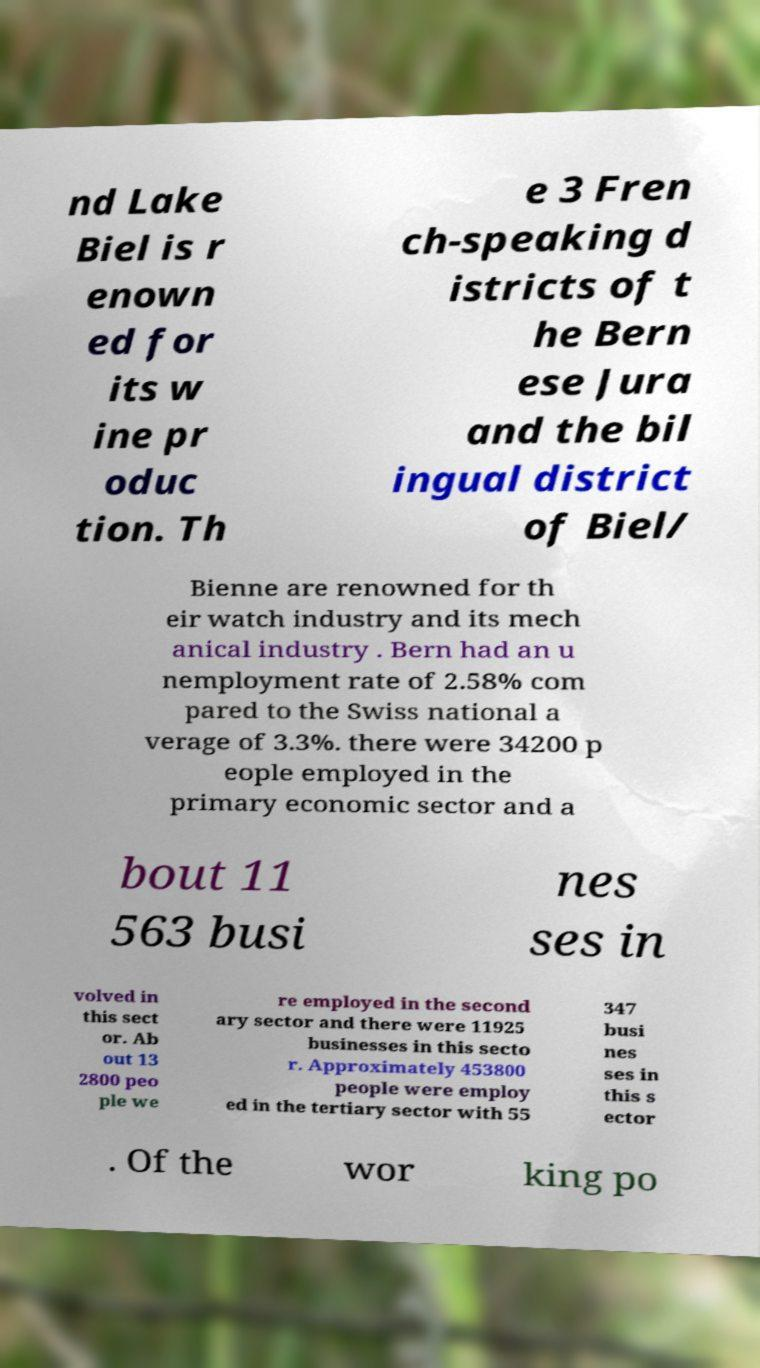What messages or text are displayed in this image? I need them in a readable, typed format. nd Lake Biel is r enown ed for its w ine pr oduc tion. Th e 3 Fren ch-speaking d istricts of t he Bern ese Jura and the bil ingual district of Biel/ Bienne are renowned for th eir watch industry and its mech anical industry . Bern had an u nemployment rate of 2.58% com pared to the Swiss national a verage of 3.3%. there were 34200 p eople employed in the primary economic sector and a bout 11 563 busi nes ses in volved in this sect or. Ab out 13 2800 peo ple we re employed in the second ary sector and there were 11925 businesses in this secto r. Approximately 453800 people were employ ed in the tertiary sector with 55 347 busi nes ses in this s ector . Of the wor king po 